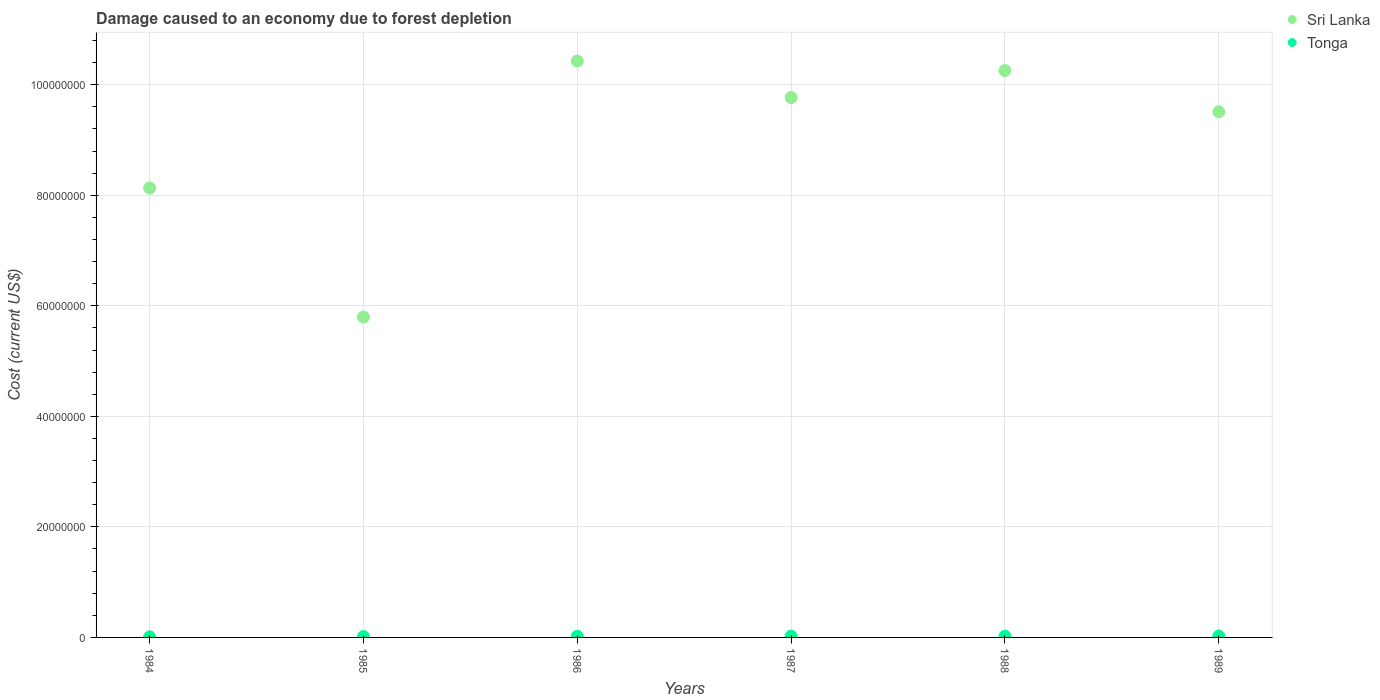What is the cost of damage caused due to forest depletion in Sri Lanka in 1986?
Make the answer very short. 1.04e+08. Across all years, what is the maximum cost of damage caused due to forest depletion in Sri Lanka?
Keep it short and to the point. 1.04e+08. Across all years, what is the minimum cost of damage caused due to forest depletion in Tonga?
Your response must be concise. 1.10e+05. In which year was the cost of damage caused due to forest depletion in Sri Lanka maximum?
Offer a very short reply. 1986. What is the total cost of damage caused due to forest depletion in Tonga in the graph?
Keep it short and to the point. 1.19e+06. What is the difference between the cost of damage caused due to forest depletion in Tonga in 1984 and that in 1987?
Provide a succinct answer. -1.25e+05. What is the difference between the cost of damage caused due to forest depletion in Tonga in 1986 and the cost of damage caused due to forest depletion in Sri Lanka in 1987?
Give a very brief answer. -9.75e+07. What is the average cost of damage caused due to forest depletion in Sri Lanka per year?
Give a very brief answer. 8.98e+07. In the year 1987, what is the difference between the cost of damage caused due to forest depletion in Sri Lanka and cost of damage caused due to forest depletion in Tonga?
Your answer should be compact. 9.74e+07. What is the ratio of the cost of damage caused due to forest depletion in Tonga in 1984 to that in 1989?
Make the answer very short. 0.45. What is the difference between the highest and the second highest cost of damage caused due to forest depletion in Tonga?
Provide a succinct answer. 1.01e+04. What is the difference between the highest and the lowest cost of damage caused due to forest depletion in Tonga?
Your answer should be compact. 1.35e+05. Is the sum of the cost of damage caused due to forest depletion in Sri Lanka in 1984 and 1985 greater than the maximum cost of damage caused due to forest depletion in Tonga across all years?
Ensure brevity in your answer.  Yes. Is the cost of damage caused due to forest depletion in Tonga strictly greater than the cost of damage caused due to forest depletion in Sri Lanka over the years?
Your response must be concise. No. How many dotlines are there?
Ensure brevity in your answer.  2. How many years are there in the graph?
Your response must be concise. 6. Does the graph contain grids?
Your answer should be compact. Yes. Where does the legend appear in the graph?
Your response must be concise. Top right. What is the title of the graph?
Give a very brief answer. Damage caused to an economy due to forest depletion. What is the label or title of the X-axis?
Make the answer very short. Years. What is the label or title of the Y-axis?
Keep it short and to the point. Cost (current US$). What is the Cost (current US$) of Sri Lanka in 1984?
Keep it short and to the point. 8.13e+07. What is the Cost (current US$) in Tonga in 1984?
Your answer should be compact. 1.10e+05. What is the Cost (current US$) of Sri Lanka in 1985?
Keep it short and to the point. 5.80e+07. What is the Cost (current US$) of Tonga in 1985?
Offer a very short reply. 1.66e+05. What is the Cost (current US$) in Sri Lanka in 1986?
Offer a terse response. 1.04e+08. What is the Cost (current US$) in Tonga in 1986?
Your answer should be compact. 2.12e+05. What is the Cost (current US$) of Sri Lanka in 1987?
Ensure brevity in your answer.  9.77e+07. What is the Cost (current US$) in Tonga in 1987?
Provide a succinct answer. 2.35e+05. What is the Cost (current US$) in Sri Lanka in 1988?
Offer a very short reply. 1.03e+08. What is the Cost (current US$) of Tonga in 1988?
Offer a very short reply. 2.27e+05. What is the Cost (current US$) of Sri Lanka in 1989?
Keep it short and to the point. 9.51e+07. What is the Cost (current US$) of Tonga in 1989?
Your answer should be compact. 2.45e+05. Across all years, what is the maximum Cost (current US$) of Sri Lanka?
Provide a succinct answer. 1.04e+08. Across all years, what is the maximum Cost (current US$) of Tonga?
Your answer should be very brief. 2.45e+05. Across all years, what is the minimum Cost (current US$) of Sri Lanka?
Your answer should be compact. 5.80e+07. Across all years, what is the minimum Cost (current US$) of Tonga?
Your answer should be very brief. 1.10e+05. What is the total Cost (current US$) in Sri Lanka in the graph?
Offer a terse response. 5.39e+08. What is the total Cost (current US$) in Tonga in the graph?
Keep it short and to the point. 1.19e+06. What is the difference between the Cost (current US$) in Sri Lanka in 1984 and that in 1985?
Your answer should be compact. 2.33e+07. What is the difference between the Cost (current US$) of Tonga in 1984 and that in 1985?
Your answer should be compact. -5.64e+04. What is the difference between the Cost (current US$) in Sri Lanka in 1984 and that in 1986?
Make the answer very short. -2.30e+07. What is the difference between the Cost (current US$) of Tonga in 1984 and that in 1986?
Your response must be concise. -1.02e+05. What is the difference between the Cost (current US$) of Sri Lanka in 1984 and that in 1987?
Keep it short and to the point. -1.64e+07. What is the difference between the Cost (current US$) in Tonga in 1984 and that in 1987?
Your response must be concise. -1.25e+05. What is the difference between the Cost (current US$) of Sri Lanka in 1984 and that in 1988?
Give a very brief answer. -2.13e+07. What is the difference between the Cost (current US$) in Tonga in 1984 and that in 1988?
Your answer should be compact. -1.17e+05. What is the difference between the Cost (current US$) in Sri Lanka in 1984 and that in 1989?
Provide a succinct answer. -1.38e+07. What is the difference between the Cost (current US$) of Tonga in 1984 and that in 1989?
Your response must be concise. -1.35e+05. What is the difference between the Cost (current US$) of Sri Lanka in 1985 and that in 1986?
Provide a succinct answer. -4.63e+07. What is the difference between the Cost (current US$) in Tonga in 1985 and that in 1986?
Ensure brevity in your answer.  -4.56e+04. What is the difference between the Cost (current US$) in Sri Lanka in 1985 and that in 1987?
Provide a succinct answer. -3.97e+07. What is the difference between the Cost (current US$) of Tonga in 1985 and that in 1987?
Give a very brief answer. -6.81e+04. What is the difference between the Cost (current US$) of Sri Lanka in 1985 and that in 1988?
Keep it short and to the point. -4.46e+07. What is the difference between the Cost (current US$) in Tonga in 1985 and that in 1988?
Keep it short and to the point. -6.04e+04. What is the difference between the Cost (current US$) in Sri Lanka in 1985 and that in 1989?
Your answer should be compact. -3.71e+07. What is the difference between the Cost (current US$) of Tonga in 1985 and that in 1989?
Provide a succinct answer. -7.82e+04. What is the difference between the Cost (current US$) in Sri Lanka in 1986 and that in 1987?
Your answer should be compact. 6.60e+06. What is the difference between the Cost (current US$) in Tonga in 1986 and that in 1987?
Your answer should be very brief. -2.25e+04. What is the difference between the Cost (current US$) in Sri Lanka in 1986 and that in 1988?
Give a very brief answer. 1.71e+06. What is the difference between the Cost (current US$) in Tonga in 1986 and that in 1988?
Provide a succinct answer. -1.48e+04. What is the difference between the Cost (current US$) in Sri Lanka in 1986 and that in 1989?
Provide a succinct answer. 9.18e+06. What is the difference between the Cost (current US$) of Tonga in 1986 and that in 1989?
Your answer should be very brief. -3.26e+04. What is the difference between the Cost (current US$) in Sri Lanka in 1987 and that in 1988?
Offer a terse response. -4.89e+06. What is the difference between the Cost (current US$) of Tonga in 1987 and that in 1988?
Give a very brief answer. 7682.08. What is the difference between the Cost (current US$) in Sri Lanka in 1987 and that in 1989?
Offer a very short reply. 2.57e+06. What is the difference between the Cost (current US$) in Tonga in 1987 and that in 1989?
Your answer should be very brief. -1.01e+04. What is the difference between the Cost (current US$) in Sri Lanka in 1988 and that in 1989?
Your answer should be compact. 7.47e+06. What is the difference between the Cost (current US$) in Tonga in 1988 and that in 1989?
Provide a succinct answer. -1.78e+04. What is the difference between the Cost (current US$) of Sri Lanka in 1984 and the Cost (current US$) of Tonga in 1985?
Provide a succinct answer. 8.11e+07. What is the difference between the Cost (current US$) in Sri Lanka in 1984 and the Cost (current US$) in Tonga in 1986?
Provide a short and direct response. 8.11e+07. What is the difference between the Cost (current US$) in Sri Lanka in 1984 and the Cost (current US$) in Tonga in 1987?
Provide a short and direct response. 8.11e+07. What is the difference between the Cost (current US$) of Sri Lanka in 1984 and the Cost (current US$) of Tonga in 1988?
Provide a short and direct response. 8.11e+07. What is the difference between the Cost (current US$) in Sri Lanka in 1984 and the Cost (current US$) in Tonga in 1989?
Make the answer very short. 8.11e+07. What is the difference between the Cost (current US$) in Sri Lanka in 1985 and the Cost (current US$) in Tonga in 1986?
Your answer should be very brief. 5.78e+07. What is the difference between the Cost (current US$) in Sri Lanka in 1985 and the Cost (current US$) in Tonga in 1987?
Make the answer very short. 5.77e+07. What is the difference between the Cost (current US$) in Sri Lanka in 1985 and the Cost (current US$) in Tonga in 1988?
Offer a terse response. 5.77e+07. What is the difference between the Cost (current US$) in Sri Lanka in 1985 and the Cost (current US$) in Tonga in 1989?
Your response must be concise. 5.77e+07. What is the difference between the Cost (current US$) in Sri Lanka in 1986 and the Cost (current US$) in Tonga in 1987?
Provide a short and direct response. 1.04e+08. What is the difference between the Cost (current US$) in Sri Lanka in 1986 and the Cost (current US$) in Tonga in 1988?
Offer a terse response. 1.04e+08. What is the difference between the Cost (current US$) in Sri Lanka in 1986 and the Cost (current US$) in Tonga in 1989?
Your answer should be compact. 1.04e+08. What is the difference between the Cost (current US$) of Sri Lanka in 1987 and the Cost (current US$) of Tonga in 1988?
Your response must be concise. 9.75e+07. What is the difference between the Cost (current US$) of Sri Lanka in 1987 and the Cost (current US$) of Tonga in 1989?
Your answer should be very brief. 9.74e+07. What is the difference between the Cost (current US$) of Sri Lanka in 1988 and the Cost (current US$) of Tonga in 1989?
Your answer should be very brief. 1.02e+08. What is the average Cost (current US$) in Sri Lanka per year?
Your answer should be very brief. 8.98e+07. What is the average Cost (current US$) in Tonga per year?
Your answer should be very brief. 1.99e+05. In the year 1984, what is the difference between the Cost (current US$) in Sri Lanka and Cost (current US$) in Tonga?
Make the answer very short. 8.12e+07. In the year 1985, what is the difference between the Cost (current US$) in Sri Lanka and Cost (current US$) in Tonga?
Provide a short and direct response. 5.78e+07. In the year 1986, what is the difference between the Cost (current US$) in Sri Lanka and Cost (current US$) in Tonga?
Offer a very short reply. 1.04e+08. In the year 1987, what is the difference between the Cost (current US$) of Sri Lanka and Cost (current US$) of Tonga?
Keep it short and to the point. 9.74e+07. In the year 1988, what is the difference between the Cost (current US$) in Sri Lanka and Cost (current US$) in Tonga?
Give a very brief answer. 1.02e+08. In the year 1989, what is the difference between the Cost (current US$) in Sri Lanka and Cost (current US$) in Tonga?
Provide a short and direct response. 9.49e+07. What is the ratio of the Cost (current US$) in Sri Lanka in 1984 to that in 1985?
Your answer should be compact. 1.4. What is the ratio of the Cost (current US$) of Tonga in 1984 to that in 1985?
Give a very brief answer. 0.66. What is the ratio of the Cost (current US$) of Sri Lanka in 1984 to that in 1986?
Offer a very short reply. 0.78. What is the ratio of the Cost (current US$) in Tonga in 1984 to that in 1986?
Keep it short and to the point. 0.52. What is the ratio of the Cost (current US$) of Sri Lanka in 1984 to that in 1987?
Provide a succinct answer. 0.83. What is the ratio of the Cost (current US$) in Tonga in 1984 to that in 1987?
Make the answer very short. 0.47. What is the ratio of the Cost (current US$) in Sri Lanka in 1984 to that in 1988?
Make the answer very short. 0.79. What is the ratio of the Cost (current US$) of Tonga in 1984 to that in 1988?
Give a very brief answer. 0.48. What is the ratio of the Cost (current US$) of Sri Lanka in 1984 to that in 1989?
Give a very brief answer. 0.85. What is the ratio of the Cost (current US$) of Tonga in 1984 to that in 1989?
Your answer should be compact. 0.45. What is the ratio of the Cost (current US$) of Sri Lanka in 1985 to that in 1986?
Provide a short and direct response. 0.56. What is the ratio of the Cost (current US$) of Tonga in 1985 to that in 1986?
Offer a very short reply. 0.78. What is the ratio of the Cost (current US$) of Sri Lanka in 1985 to that in 1987?
Ensure brevity in your answer.  0.59. What is the ratio of the Cost (current US$) of Tonga in 1985 to that in 1987?
Provide a succinct answer. 0.71. What is the ratio of the Cost (current US$) of Sri Lanka in 1985 to that in 1988?
Ensure brevity in your answer.  0.57. What is the ratio of the Cost (current US$) of Tonga in 1985 to that in 1988?
Keep it short and to the point. 0.73. What is the ratio of the Cost (current US$) of Sri Lanka in 1985 to that in 1989?
Your answer should be very brief. 0.61. What is the ratio of the Cost (current US$) in Tonga in 1985 to that in 1989?
Provide a succinct answer. 0.68. What is the ratio of the Cost (current US$) of Sri Lanka in 1986 to that in 1987?
Offer a very short reply. 1.07. What is the ratio of the Cost (current US$) in Tonga in 1986 to that in 1987?
Your answer should be very brief. 0.9. What is the ratio of the Cost (current US$) of Sri Lanka in 1986 to that in 1988?
Give a very brief answer. 1.02. What is the ratio of the Cost (current US$) in Tonga in 1986 to that in 1988?
Offer a very short reply. 0.93. What is the ratio of the Cost (current US$) in Sri Lanka in 1986 to that in 1989?
Provide a short and direct response. 1.1. What is the ratio of the Cost (current US$) of Tonga in 1986 to that in 1989?
Provide a succinct answer. 0.87. What is the ratio of the Cost (current US$) in Sri Lanka in 1987 to that in 1988?
Your answer should be very brief. 0.95. What is the ratio of the Cost (current US$) in Tonga in 1987 to that in 1988?
Offer a very short reply. 1.03. What is the ratio of the Cost (current US$) of Sri Lanka in 1987 to that in 1989?
Keep it short and to the point. 1.03. What is the ratio of the Cost (current US$) of Tonga in 1987 to that in 1989?
Your answer should be very brief. 0.96. What is the ratio of the Cost (current US$) in Sri Lanka in 1988 to that in 1989?
Your answer should be compact. 1.08. What is the ratio of the Cost (current US$) in Tonga in 1988 to that in 1989?
Provide a short and direct response. 0.93. What is the difference between the highest and the second highest Cost (current US$) of Sri Lanka?
Make the answer very short. 1.71e+06. What is the difference between the highest and the second highest Cost (current US$) of Tonga?
Give a very brief answer. 1.01e+04. What is the difference between the highest and the lowest Cost (current US$) of Sri Lanka?
Your answer should be very brief. 4.63e+07. What is the difference between the highest and the lowest Cost (current US$) in Tonga?
Offer a very short reply. 1.35e+05. 